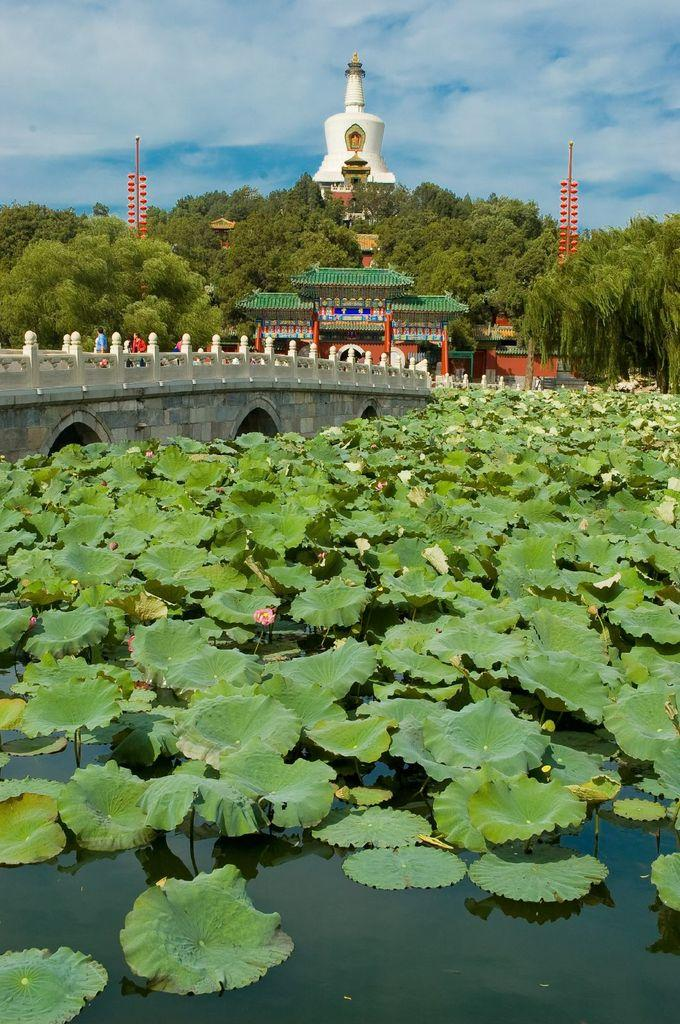What is floating on the water in the image? There are flower pods on the water in the image. What structure can be seen crossing the water? There is a bridge in the image. Who or what is on the bridge? People are present on the bridge. What type of structures can be seen in the background? There are buildings in the image. What type of vegetation is visible in the image? Trees are visible in the image. Can you see any notes being passed between the people on the bridge? There is no indication of notes being passed between the people on the bridge in the image. How many spiders are crawling on the bridge in the image? There are no spiders visible on the bridge or anywhere else in the image. 